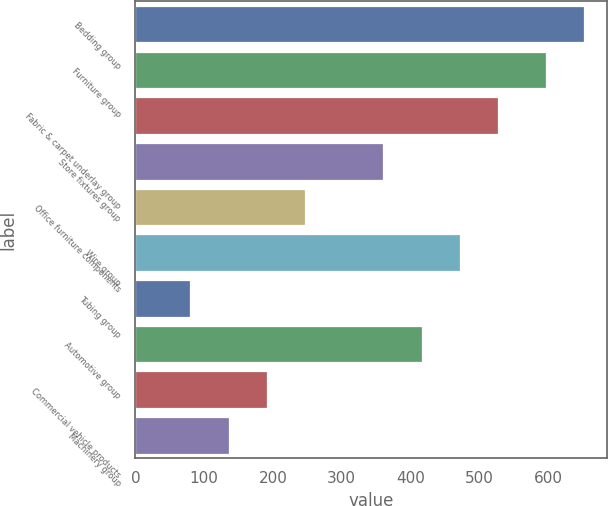Convert chart to OTSL. <chart><loc_0><loc_0><loc_500><loc_500><bar_chart><fcel>Bedding group<fcel>Furniture group<fcel>Fabric & carpet underlay group<fcel>Store fixtures group<fcel>Office furniture components<fcel>Wire group<fcel>Tubing group<fcel>Automotive group<fcel>Commercial vehicle products<fcel>Machinery group<nl><fcel>652.7<fcel>596.8<fcel>527.9<fcel>360.2<fcel>247.3<fcel>472<fcel>79.6<fcel>416.1<fcel>191.4<fcel>135.5<nl></chart> 